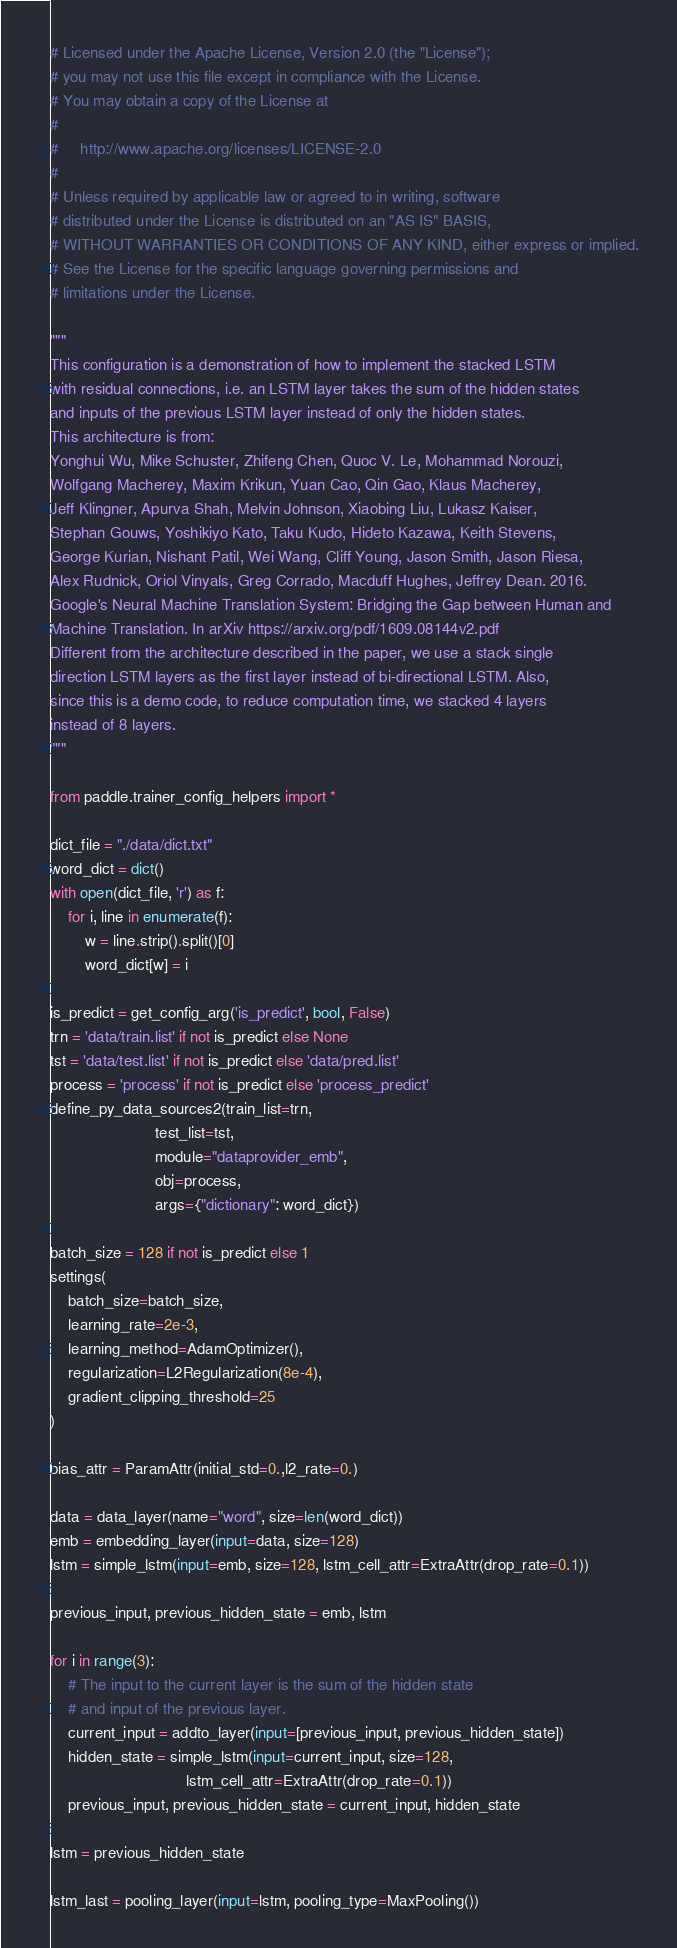Convert code to text. <code><loc_0><loc_0><loc_500><loc_500><_Python_># Licensed under the Apache License, Version 2.0 (the "License");
# you may not use this file except in compliance with the License.
# You may obtain a copy of the License at
#
#     http://www.apache.org/licenses/LICENSE-2.0
#
# Unless required by applicable law or agreed to in writing, software
# distributed under the License is distributed on an "AS IS" BASIS,
# WITHOUT WARRANTIES OR CONDITIONS OF ANY KIND, either express or implied.
# See the License for the specific language governing permissions and
# limitations under the License.

"""
This configuration is a demonstration of how to implement the stacked LSTM
with residual connections, i.e. an LSTM layer takes the sum of the hidden states
and inputs of the previous LSTM layer instead of only the hidden states.
This architecture is from:
Yonghui Wu, Mike Schuster, Zhifeng Chen, Quoc V. Le, Mohammad Norouzi,
Wolfgang Macherey, Maxim Krikun, Yuan Cao, Qin Gao, Klaus Macherey,
Jeff Klingner, Apurva Shah, Melvin Johnson, Xiaobing Liu, Lukasz Kaiser,
Stephan Gouws, Yoshikiyo Kato, Taku Kudo, Hideto Kazawa, Keith Stevens,
George Kurian, Nishant Patil, Wei Wang, Cliff Young, Jason Smith, Jason Riesa,
Alex Rudnick, Oriol Vinyals, Greg Corrado, Macduff Hughes, Jeffrey Dean. 2016.
Google's Neural Machine Translation System: Bridging the Gap between Human and
Machine Translation. In arXiv https://arxiv.org/pdf/1609.08144v2.pdf
Different from the architecture described in the paper, we use a stack single
direction LSTM layers as the first layer instead of bi-directional LSTM. Also,
since this is a demo code, to reduce computation time, we stacked 4 layers
instead of 8 layers.
"""

from paddle.trainer_config_helpers import *

dict_file = "./data/dict.txt"
word_dict = dict()
with open(dict_file, 'r') as f:
    for i, line in enumerate(f):
        w = line.strip().split()[0]
        word_dict[w] = i

is_predict = get_config_arg('is_predict', bool, False)
trn = 'data/train.list' if not is_predict else None
tst = 'data/test.list' if not is_predict else 'data/pred.list'
process = 'process' if not is_predict else 'process_predict'
define_py_data_sources2(train_list=trn,
                        test_list=tst,
                        module="dataprovider_emb",
                        obj=process,
                        args={"dictionary": word_dict})

batch_size = 128 if not is_predict else 1
settings(
    batch_size=batch_size,
    learning_rate=2e-3,
    learning_method=AdamOptimizer(),
    regularization=L2Regularization(8e-4),
    gradient_clipping_threshold=25
)

bias_attr = ParamAttr(initial_std=0.,l2_rate=0.)

data = data_layer(name="word", size=len(word_dict))
emb = embedding_layer(input=data, size=128)
lstm = simple_lstm(input=emb, size=128, lstm_cell_attr=ExtraAttr(drop_rate=0.1))

previous_input, previous_hidden_state = emb, lstm

for i in range(3):
    # The input to the current layer is the sum of the hidden state
    # and input of the previous layer.
    current_input = addto_layer(input=[previous_input, previous_hidden_state])
    hidden_state = simple_lstm(input=current_input, size=128,
                               lstm_cell_attr=ExtraAttr(drop_rate=0.1))
    previous_input, previous_hidden_state = current_input, hidden_state

lstm = previous_hidden_state

lstm_last = pooling_layer(input=lstm, pooling_type=MaxPooling())</code> 